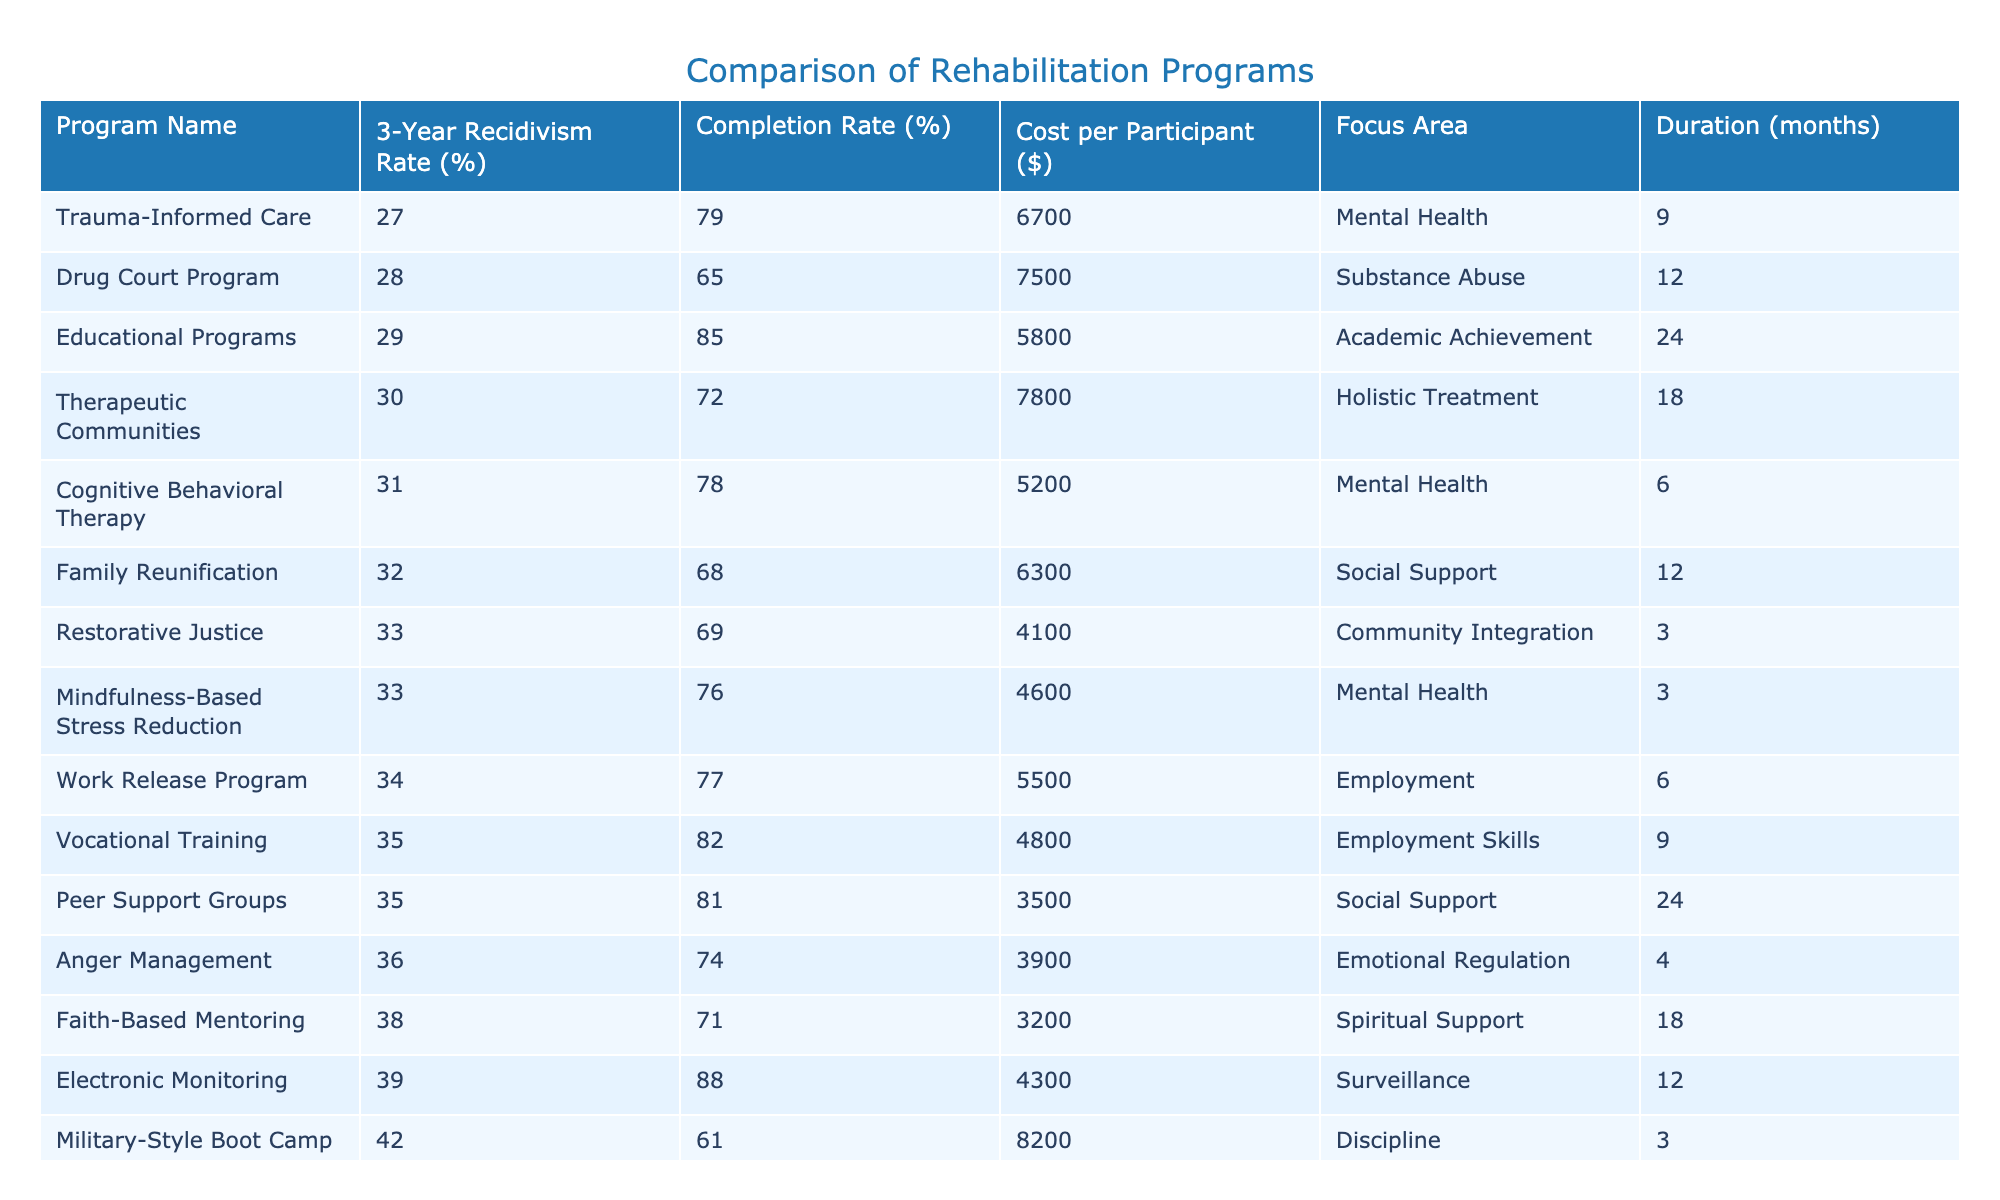What is the 3-Year Recidivism Rate for the Drug Court Program? The table shows that the 3-Year Recidivism Rate for the Drug Court Program is listed as 28%.
Answer: 28% Which rehabilitation program has the highest completion rate? By examining the completion rates from the table, we can see that the Educational Programs have the highest completion rate at 85%.
Answer: 85% Is the cost per participant for the Faith-Based Mentoring program greater than for the Trauma-Informed Care program? The table shows that the cost per participant for Faith-Based Mentoring is $3,200, while for Trauma-Informed Care it is $6,700. Since $3,200 is less than $6,700, the answer is no.
Answer: No What is the average 3-Year Recidivism Rate among the programs focusing on Mental Health? The Mental Health programs in the table are Cognitive Behavioral Therapy (31%), Trauma-Informed Care (27%), and Mindfulness-Based Stress Reduction (33%). The average is calculated as (31 + 27 + 33) / 3 = 30.33%.
Answer: 30.33% Which program has the lowest cost per participant? By looking at the cost per participant column in the table, we see that the Faith-Based Mentoring program has the lowest cost at $3,200.
Answer: $3,200 How many rehabilitation programs have a completion rate above 75%? The programs with completion rates above 75% are Cognitive Behavioral Therapy (78%), Vocational Training (82%), Educational Programs (85%), and Peer Support Groups (81%). Thus, there are four programs in total.
Answer: 4 What is the difference in completion rates between the Work Release Program and the Family Reunification program? The completion rate for the Work Release Program is 77% and for Family Reunification it is 68%. The difference is calculated as 77% - 68% = 9%.
Answer: 9% Does the Military-Style Boot Camp have a lower recidivism rate than the Vocational Training program? The Military-Style Boot Camp has a recidivism rate of 42%, while the Vocational Training program has a recidivism rate of 35%. Since 42% is greater than 35%, the answer is no.
Answer: No What is the sum of the 3-Year Recidivism Rates for programs focusing on Emotional Regulation and Social Support? The Anger Management program focusing on Emotional Regulation has a recidivism rate of 36%, and the Family Reunification program focusing on Social Support has a rate of 32%. Therefore, the sum is 36% + 32% = 68%.
Answer: 68% 